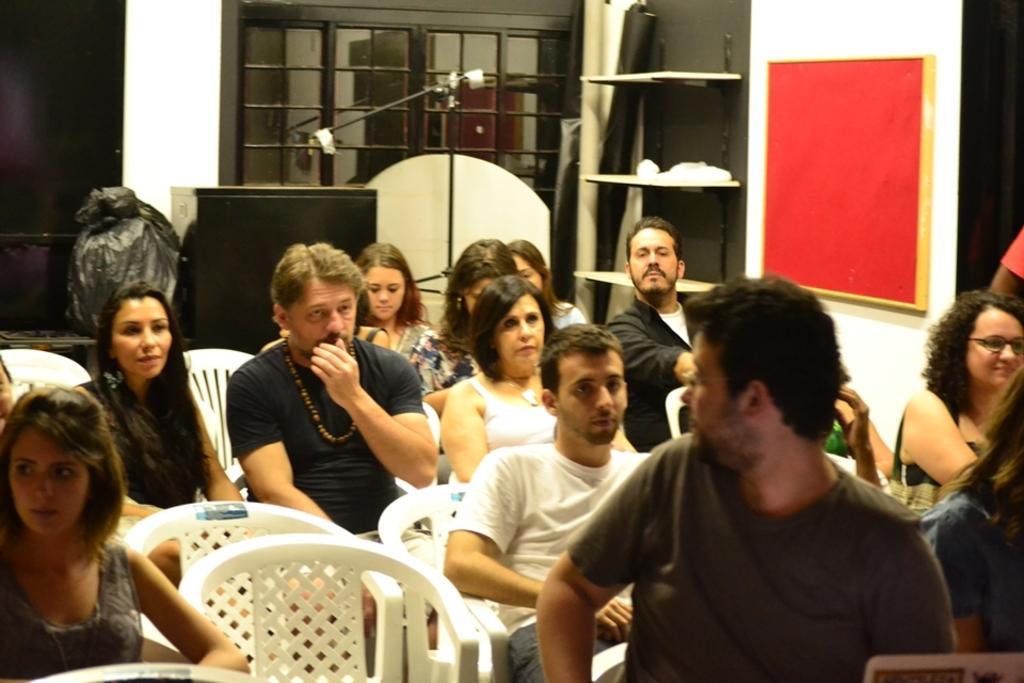Can you describe this image briefly? In this image I see number of people who are sitting on chairs and I see the red color board over here and I see the wall. In the background I see the windows over here and I see few things over here. 